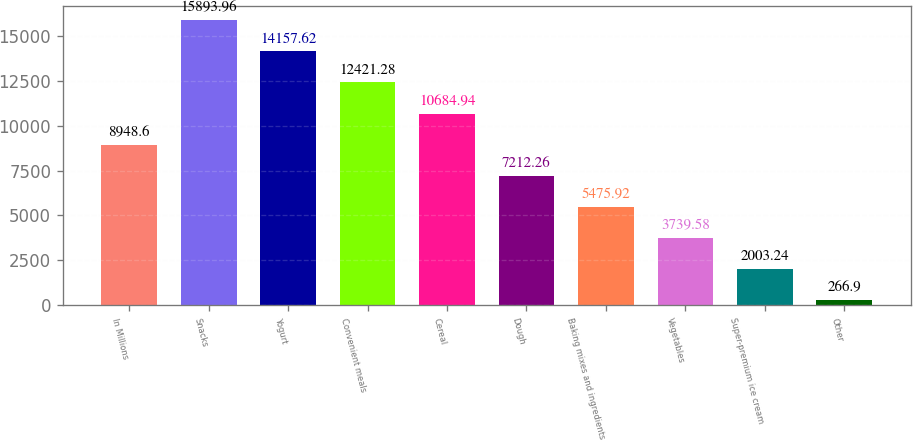<chart> <loc_0><loc_0><loc_500><loc_500><bar_chart><fcel>In Millions<fcel>Snacks<fcel>Yogurt<fcel>Convenient meals<fcel>Cereal<fcel>Dough<fcel>Baking mixes and ingredients<fcel>Vegetables<fcel>Super-premium ice cream<fcel>Other<nl><fcel>8948.6<fcel>15894<fcel>14157.6<fcel>12421.3<fcel>10684.9<fcel>7212.26<fcel>5475.92<fcel>3739.58<fcel>2003.24<fcel>266.9<nl></chart> 